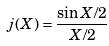<formula> <loc_0><loc_0><loc_500><loc_500>j ( X ) = \frac { \sin X / 2 } { X / 2 }</formula> 